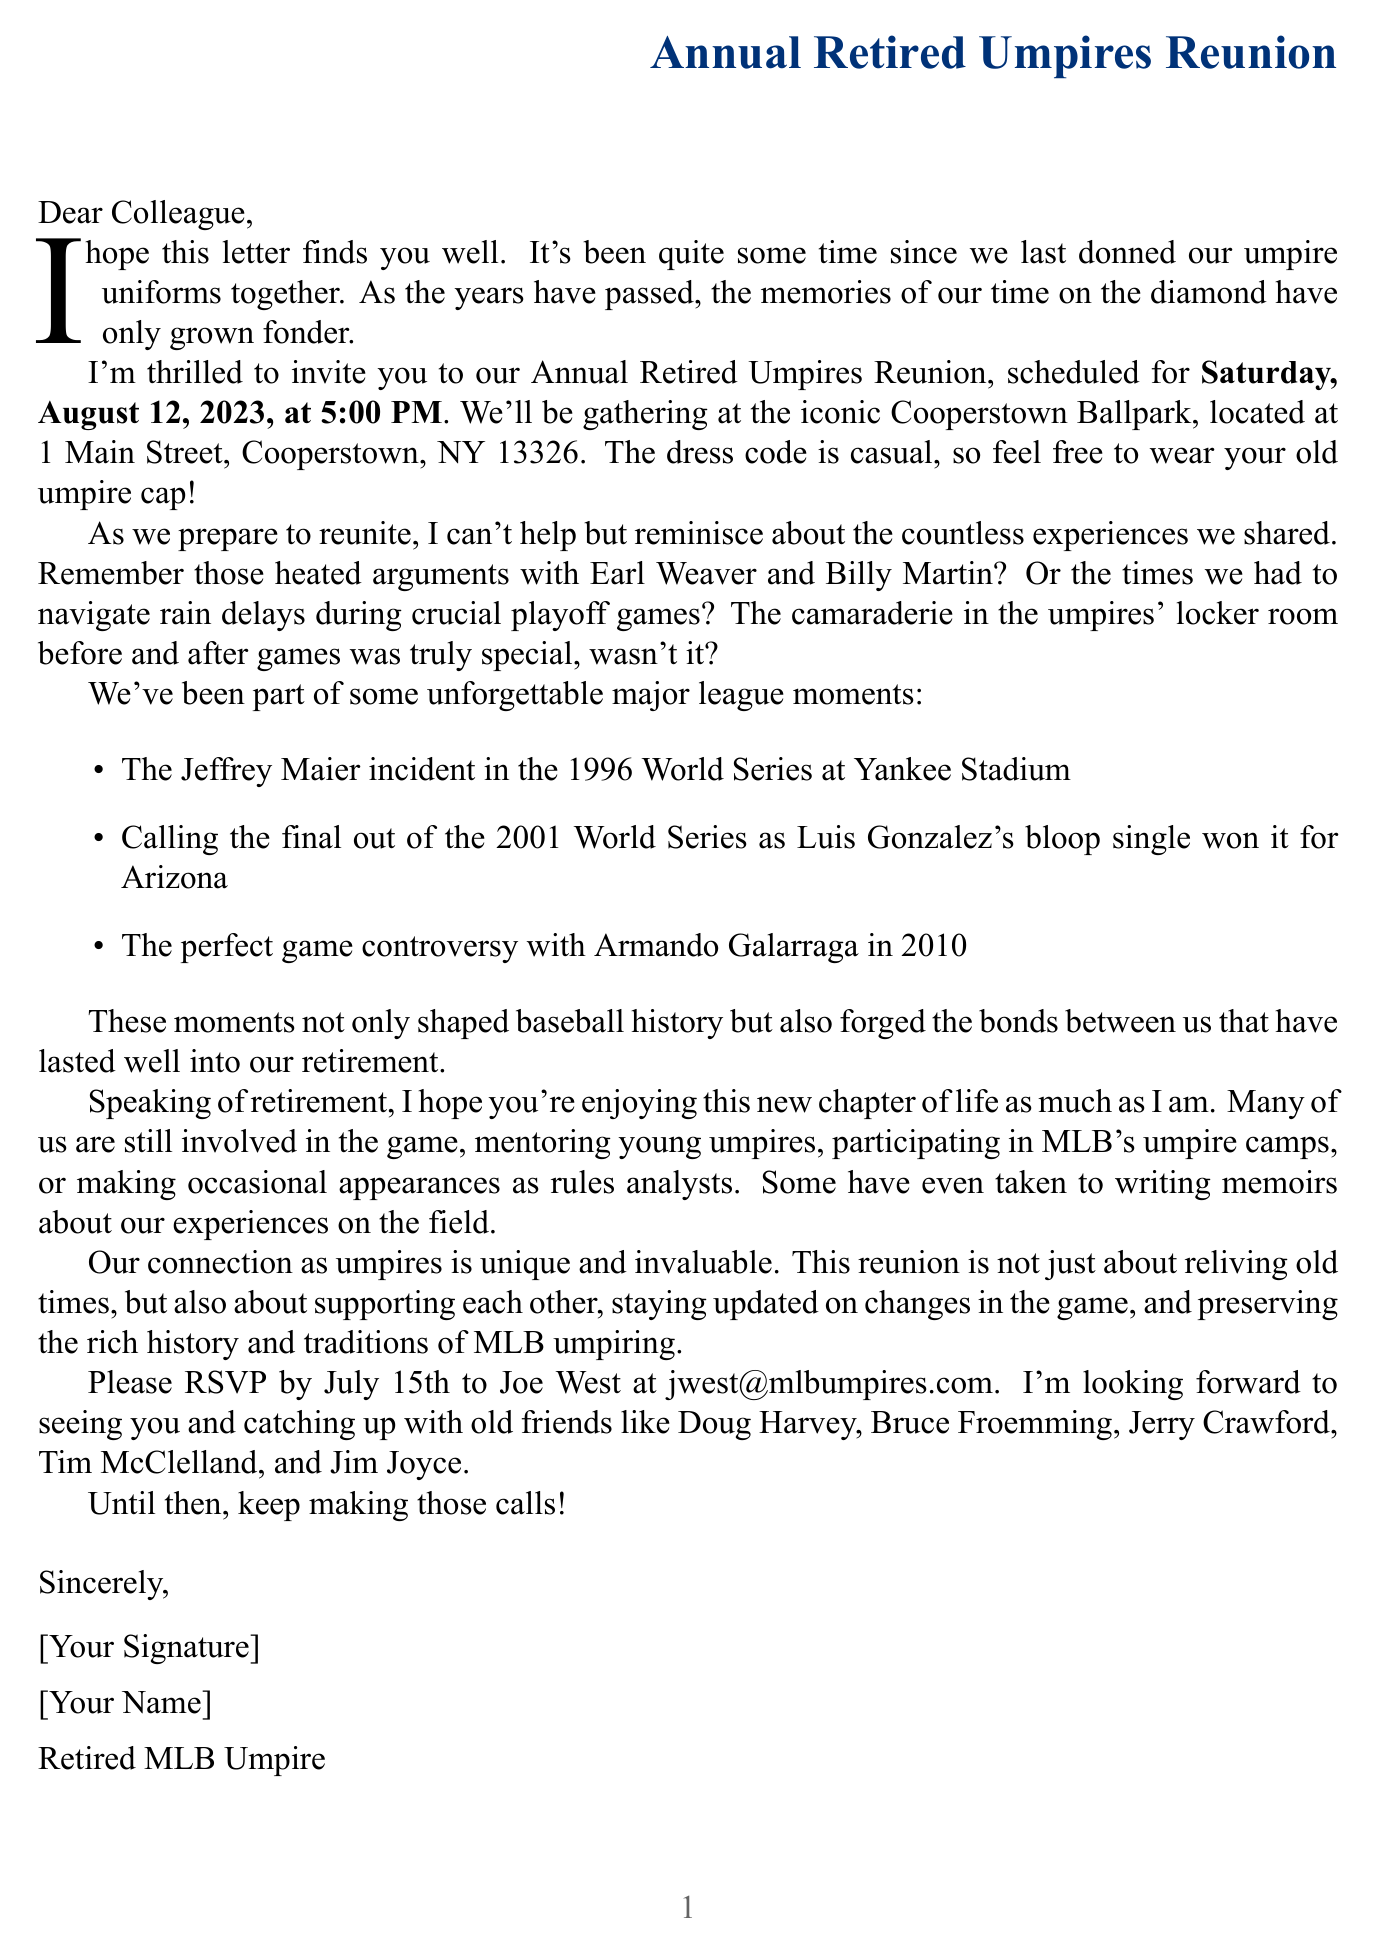What is the date of the reunion? The date of the reunion is mentioned in the invitation details, which states Saturday, August 12, 2023.
Answer: Saturday, August 12, 2023 Where will the reunion take place? The document specifies that the reunion will be held at Cooperstown Ballpark, located at 1 Main Street, Cooperstown, NY 13326.
Answer: Cooperstown Ballpark Who should be contacted for RSVP? The document indicates that RSVPs should be sent to Joe West at the email address provided.
Answer: Joe West What type of dress code is requested for the reunion? The letter notes that the dress code is casual and encourages attendees to wear their old umpire cap.
Answer: Casual Which major league event is mentioned alongside the Jeffrey Maier incident? In discussing major league moments, the document mentions the 2001 World Series, Game 7 as another significant event.
Answer: 2001 World Series, Game 7 What is one of the current activities of retired umpires? The document lists several activities, one being mentoring young umpires in local leagues, which is a common activity among retired umpires.
Answer: Mentoring young umpires What significance does the reunion have for retired umpires? The document highlights the importance of the reunion for sharing stories, supporting each other, and preserving the history and traditions of MLB umpiring.
Answer: Sharing stories and supporting each other Which year was the perfect game controversy mentioned? The document refers to the perfect game controversy occurring in the year 2010 during its discussion of major league moments.
Answer: 2010 